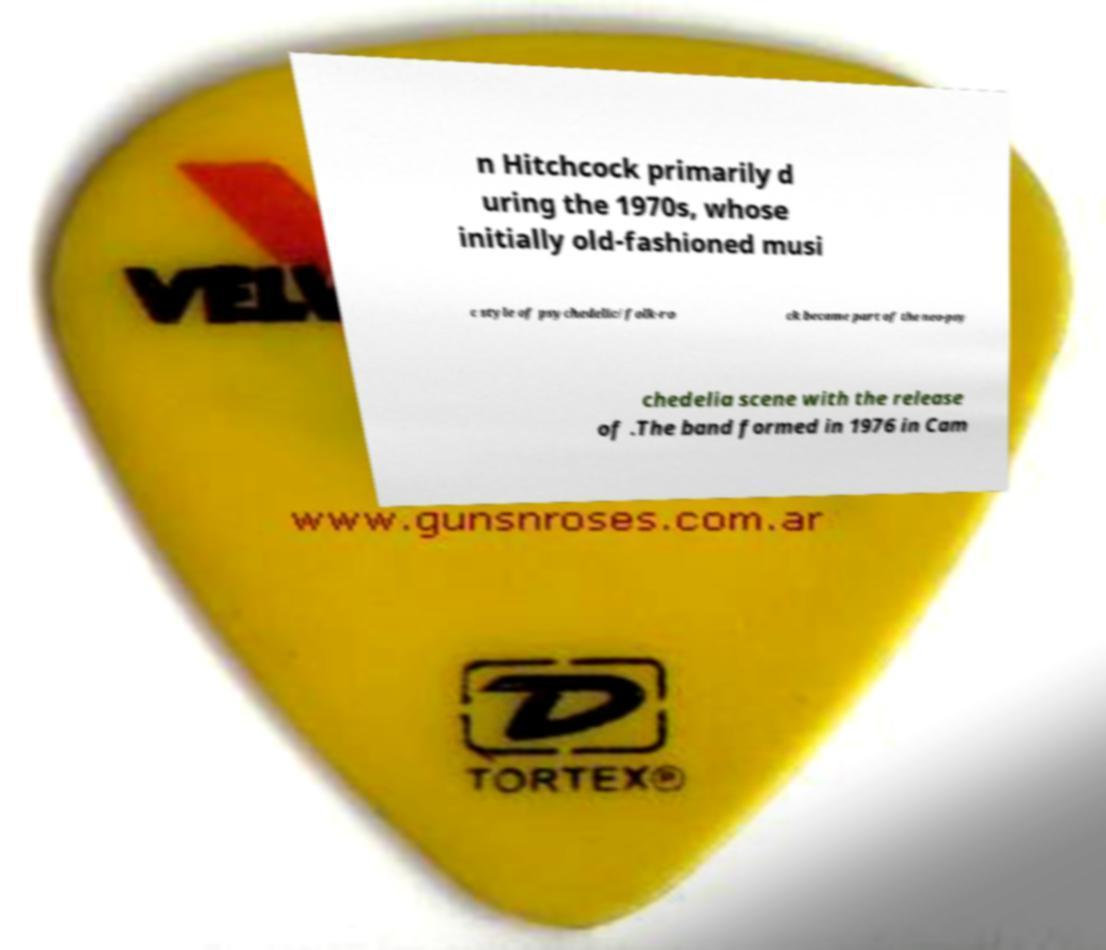Could you extract and type out the text from this image? n Hitchcock primarily d uring the 1970s, whose initially old-fashioned musi c style of psychedelic/folk-ro ck became part of the neo-psy chedelia scene with the release of .The band formed in 1976 in Cam 